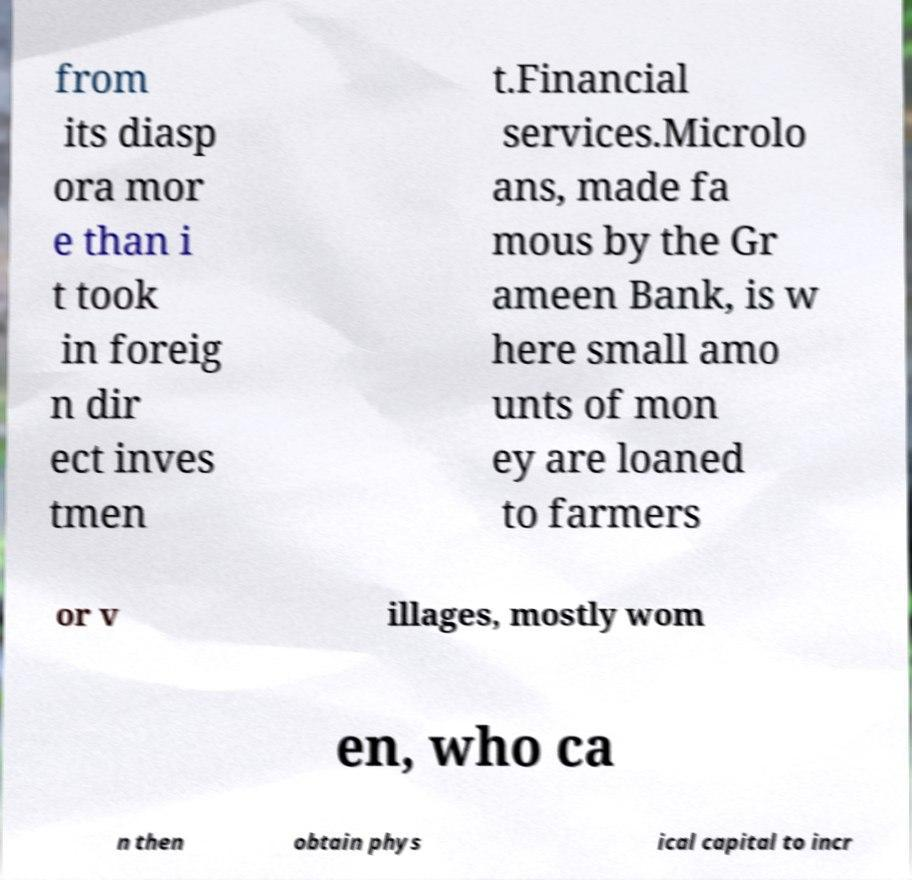Please identify and transcribe the text found in this image. from its diasp ora mor e than i t took in foreig n dir ect inves tmen t.Financial services.Microlo ans, made fa mous by the Gr ameen Bank, is w here small amo unts of mon ey are loaned to farmers or v illages, mostly wom en, who ca n then obtain phys ical capital to incr 